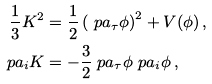Convert formula to latex. <formula><loc_0><loc_0><loc_500><loc_500>\frac { 1 } { 3 } K ^ { 2 } & = \frac { 1 } { 2 } \left ( \ p a _ { \tau } \phi \right ) ^ { 2 } + V ( \phi ) \, , \\ \ p a _ { i } K & = - \frac { 3 } { 2 } \ p a _ { \tau } \phi \ p a _ { i } \phi \, ,</formula> 